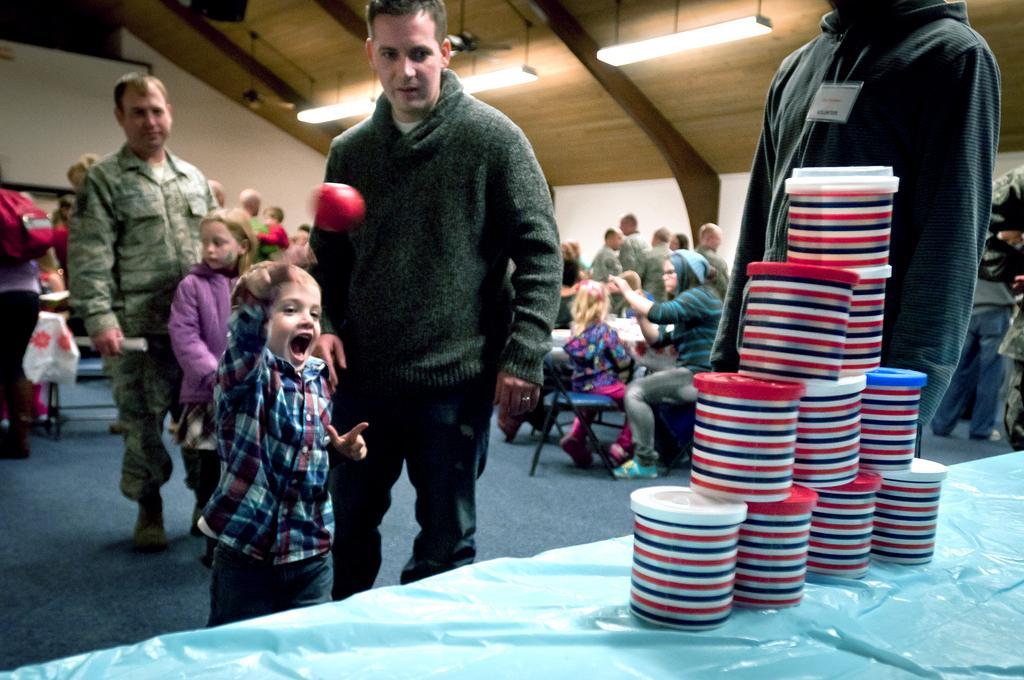Describe this image in one or two sentences. At the bottom, we see a table which is covered with a blue color sheet. We see the plastic boxes are placed on the table in the pyramid shape. Beside that, we see a man is standing. In the middle, we see a man is standing and beside him, we see a boy is throwing a ball. Behind him, we see a man and a girl are standing. We see the people are standing and some of them are sitting on the chairs. In the background, we see a wall. At the top, we see the lights and the roof of the building. 